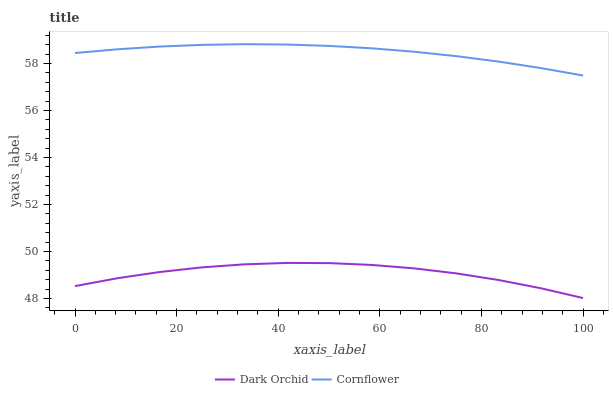Does Dark Orchid have the minimum area under the curve?
Answer yes or no. Yes. Does Cornflower have the maximum area under the curve?
Answer yes or no. Yes. Does Dark Orchid have the maximum area under the curve?
Answer yes or no. No. Is Cornflower the smoothest?
Answer yes or no. Yes. Is Dark Orchid the roughest?
Answer yes or no. Yes. Is Dark Orchid the smoothest?
Answer yes or no. No. Does Cornflower have the highest value?
Answer yes or no. Yes. Does Dark Orchid have the highest value?
Answer yes or no. No. Is Dark Orchid less than Cornflower?
Answer yes or no. Yes. Is Cornflower greater than Dark Orchid?
Answer yes or no. Yes. Does Dark Orchid intersect Cornflower?
Answer yes or no. No. 